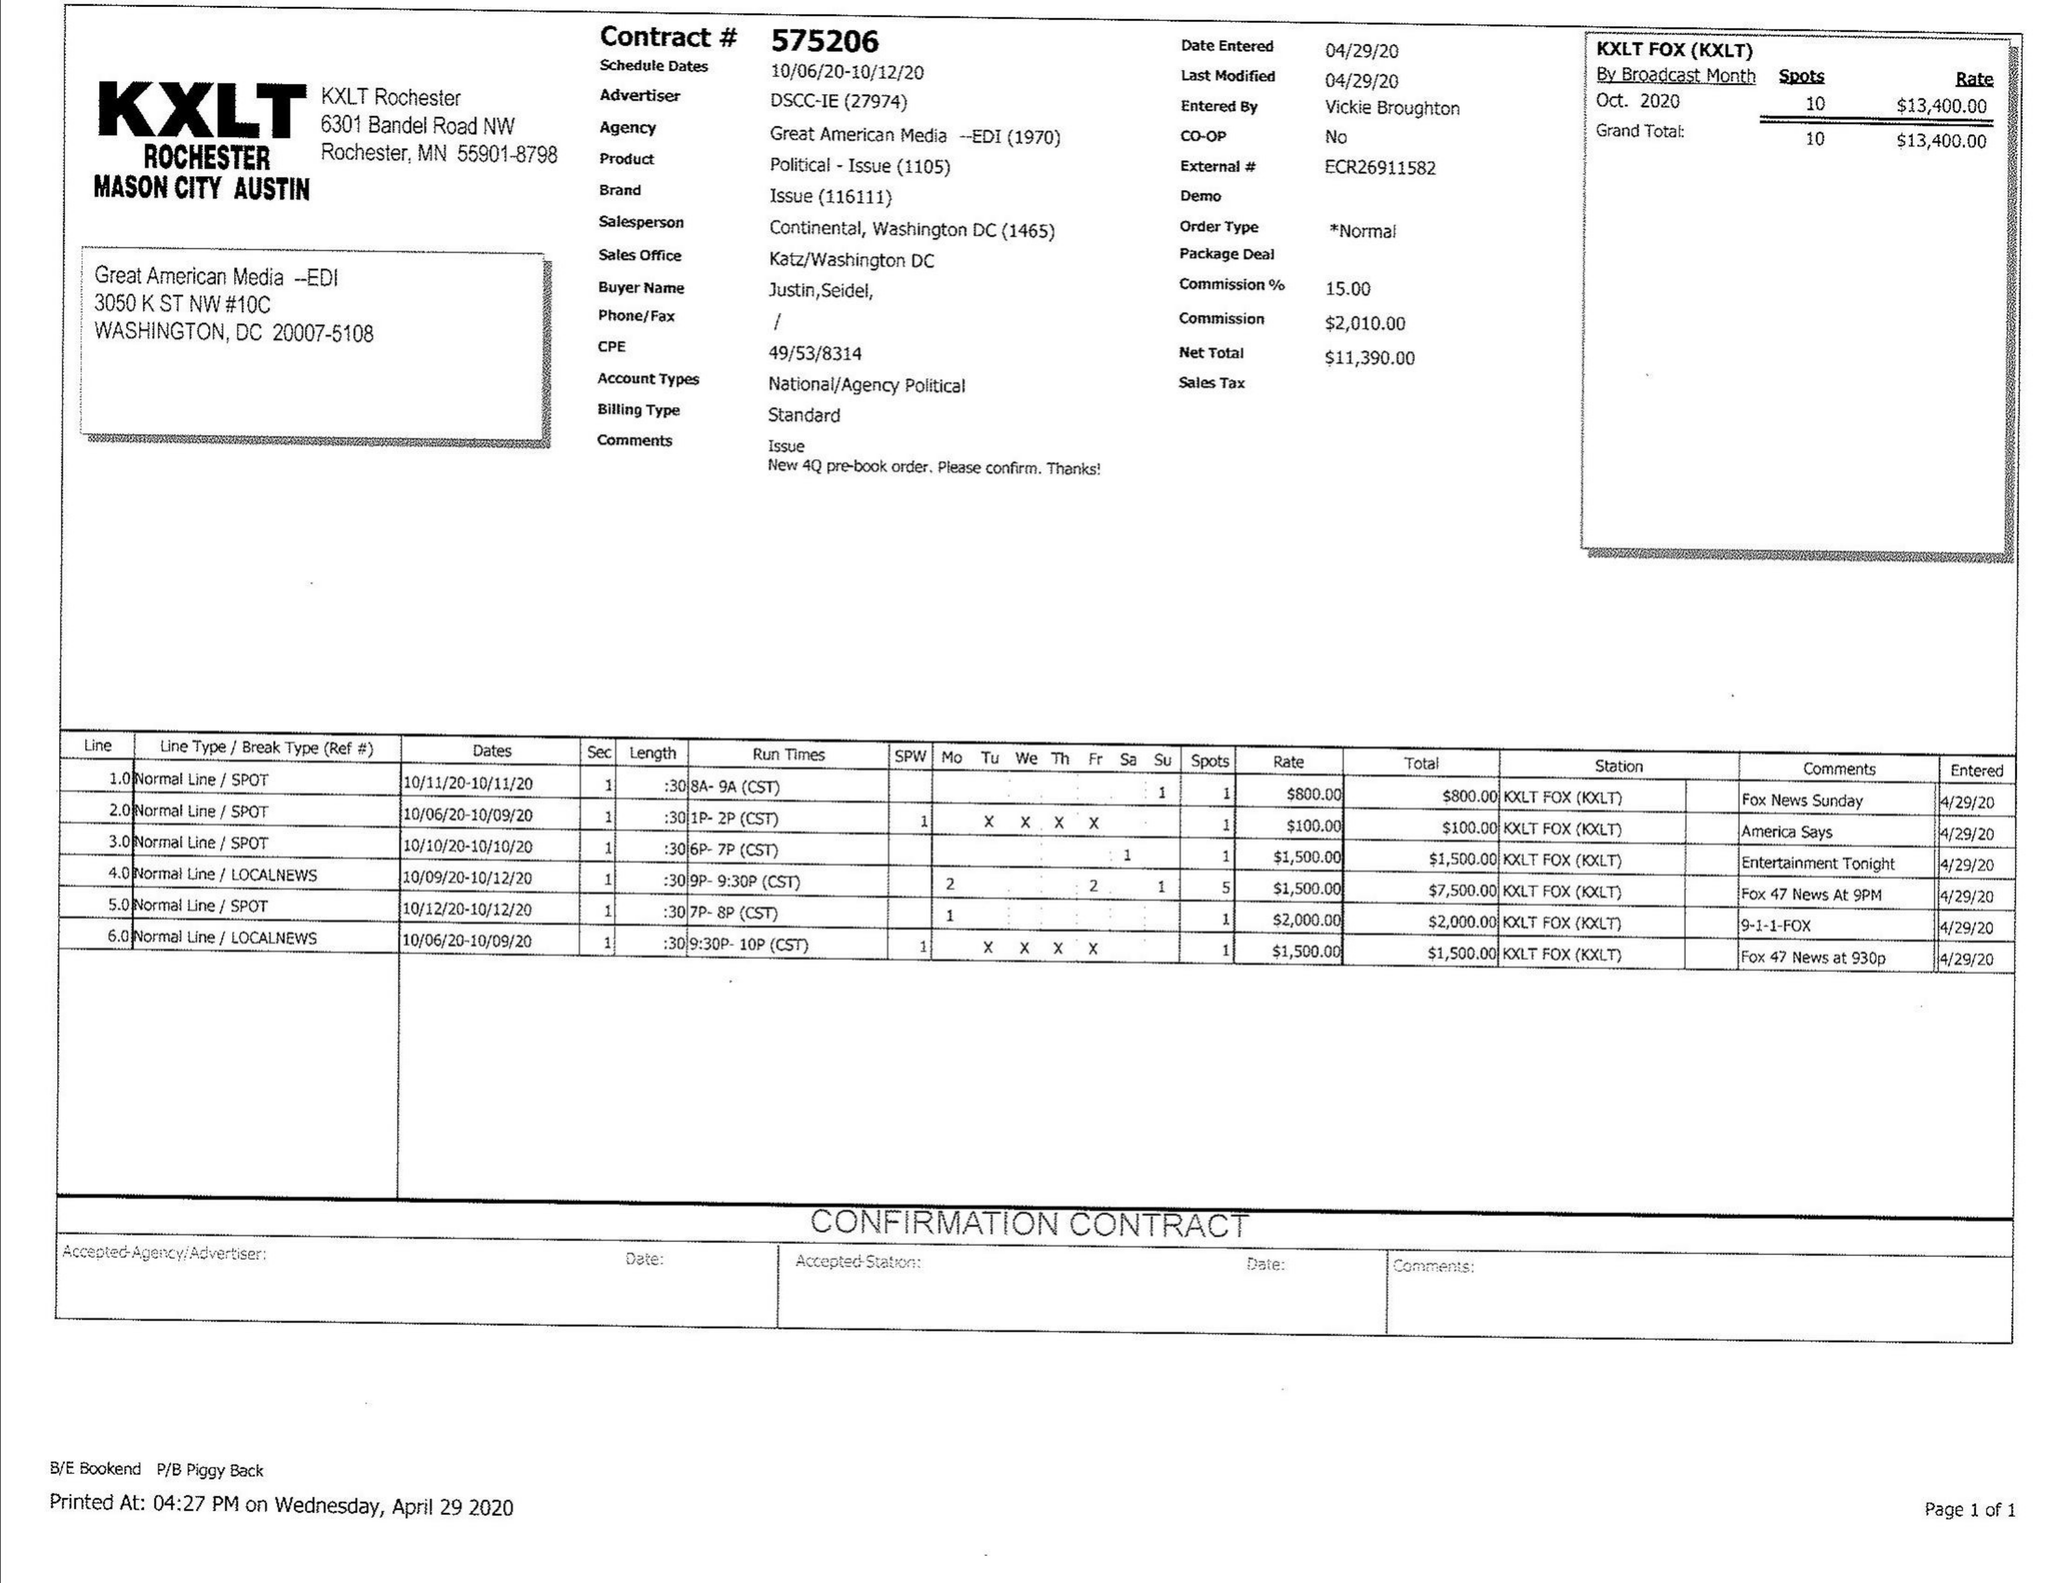What is the value for the advertiser?
Answer the question using a single word or phrase. DSCC-IE 